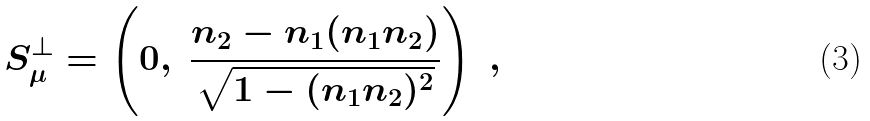<formula> <loc_0><loc_0><loc_500><loc_500>S _ { \mu } ^ { \bot } = \left ( 0 , \ \frac { n _ { 2 } - n _ { 1 } ( n _ { 1 } n _ { 2 } ) } { \sqrt { 1 - { ( n _ { 1 } n _ { 2 } ) ^ { 2 } } } } \right ) \ ,</formula> 